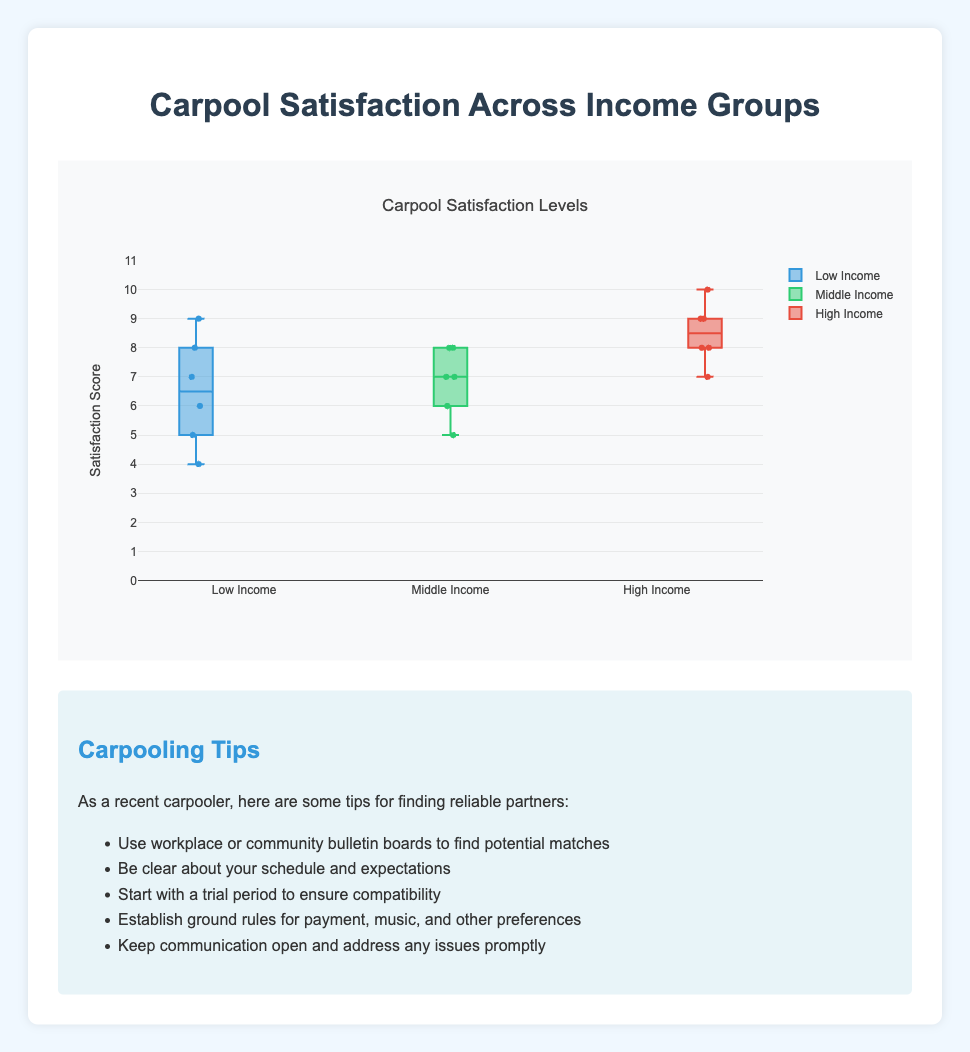What is the title of the figure? The title of a figure is usually displayed at the top and summarizes what the figure is about. In this case, the title is "Carpool Satisfaction Levels"
Answer: Carpool Satisfaction Levels What is the highest satisfaction score in the High Income group? The highest satisfaction score in the High Income group can be identified by looking at the topmost point in the box for that group. From the given data, Olivia Scott has the highest score of 10.
Answer: 10 How many data points (participants) are displayed for the Middle Income group? To find the number of data points for the Middle Income group, one can simply count the participants listed under that group.
Answer: 6 Which income group has the most variability in carpool satisfaction? The variability in a box plot can be assessed by the interquartile range (IQR) and the length of the whiskers. A larger IQR and longer whiskers indicate more variability. By visually inspecting the box plot, the Low Income group seems to have the most variability.
Answer: Low Income Compare the median satisfaction score of the Low Income group to the Middle Income group. The median is represented by the line inside the box. For the Low Income group, the median is around 6. For the Middle Income group, the median is around 7.
Answer: The Middle Income group's median is higher What is the interquartile range (IQR) for the High Income group? The IQR is calculated by subtracting the first quartile (Q1) from the third quartile (Q3). For the High Income group, Q1 is around 8 and Q3 is around 9, so IQR = 9 - 8.
Answer: 1 Are there any outliers in the Low Income group? In a box plot, outliers are typically represented as individual points outside the whiskers. Visually inspecting the box plot for the Low Income group, there is a data point at around 4 which is an outlier.
Answer: Yes Which income group has the highest median satisfaction score? By looking at the medians represented by the lines inside the boxes, the High Income group has the highest median score.
Answer: High Income What is the range of satisfaction scores in the Middle Income group? The range is the difference between the highest and lowest values. From the box plot, the Middle Income group ranges from 5 to 8.
Answer: 3 